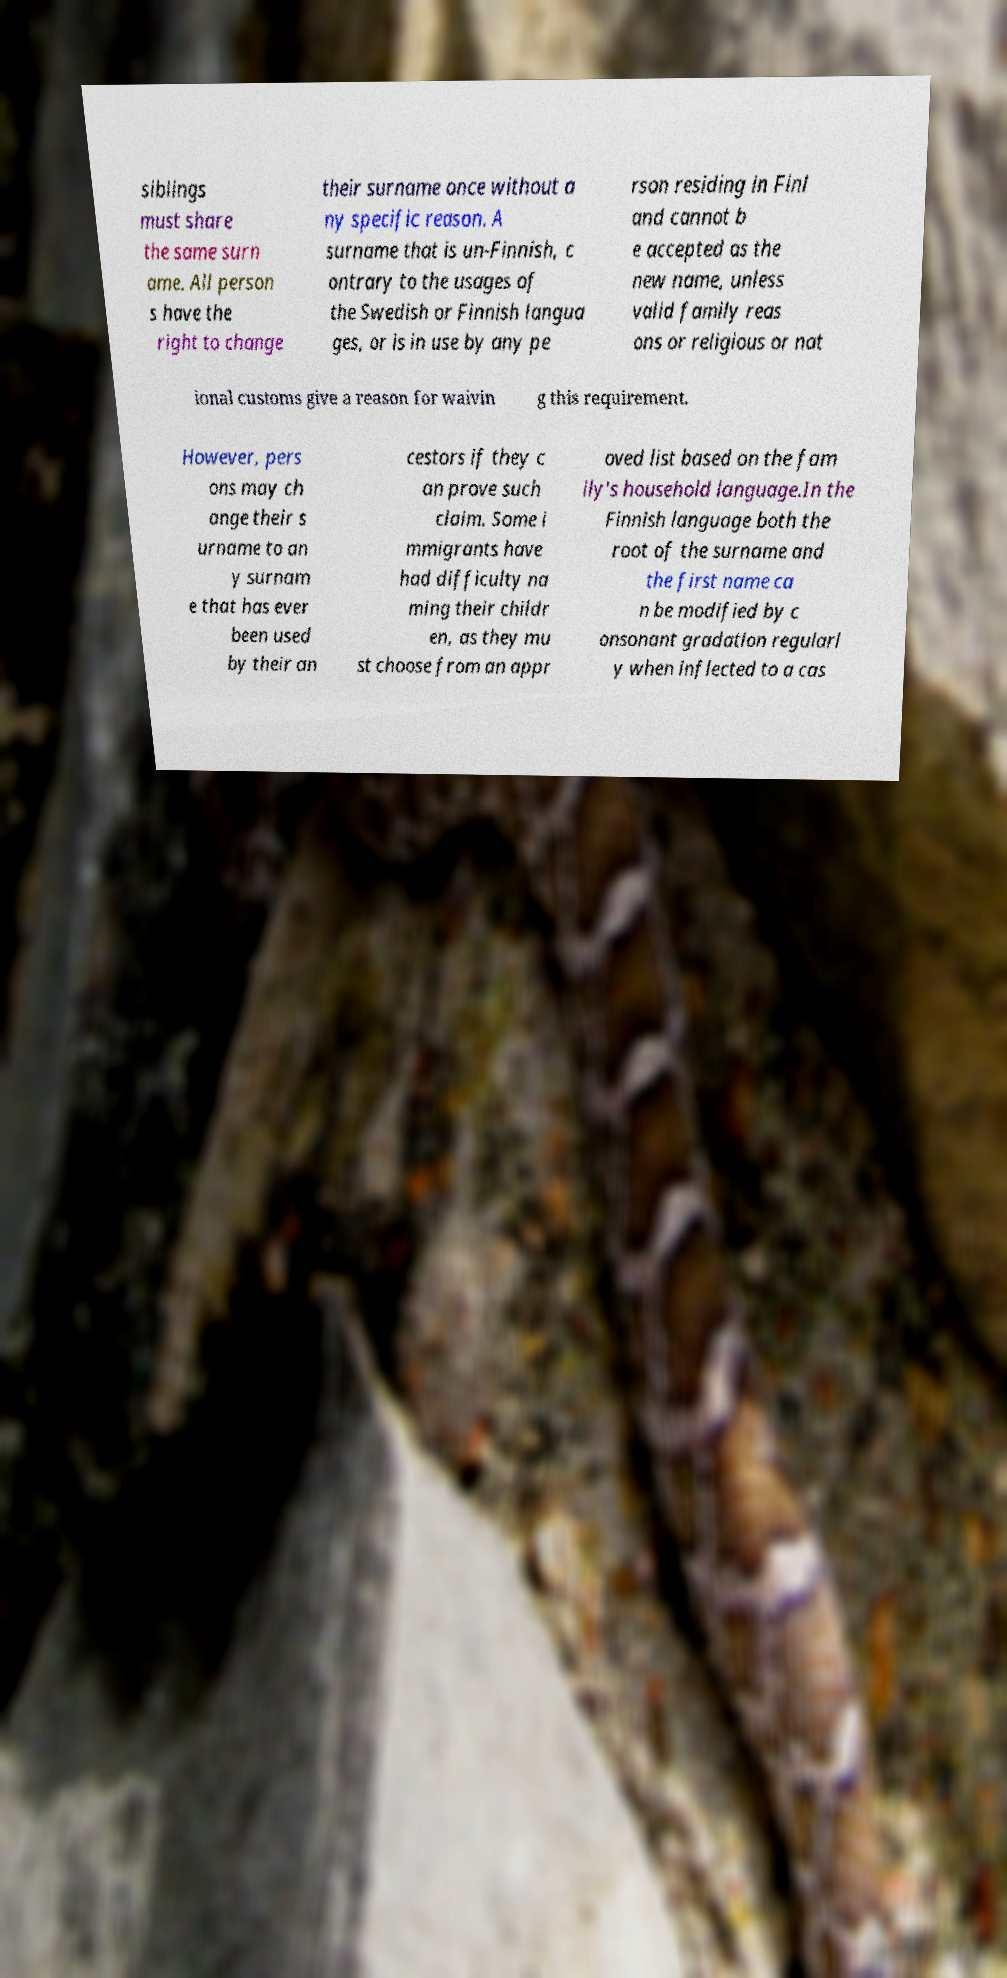There's text embedded in this image that I need extracted. Can you transcribe it verbatim? siblings must share the same surn ame. All person s have the right to change their surname once without a ny specific reason. A surname that is un-Finnish, c ontrary to the usages of the Swedish or Finnish langua ges, or is in use by any pe rson residing in Finl and cannot b e accepted as the new name, unless valid family reas ons or religious or nat ional customs give a reason for waivin g this requirement. However, pers ons may ch ange their s urname to an y surnam e that has ever been used by their an cestors if they c an prove such claim. Some i mmigrants have had difficulty na ming their childr en, as they mu st choose from an appr oved list based on the fam ily's household language.In the Finnish language both the root of the surname and the first name ca n be modified by c onsonant gradation regularl y when inflected to a cas 